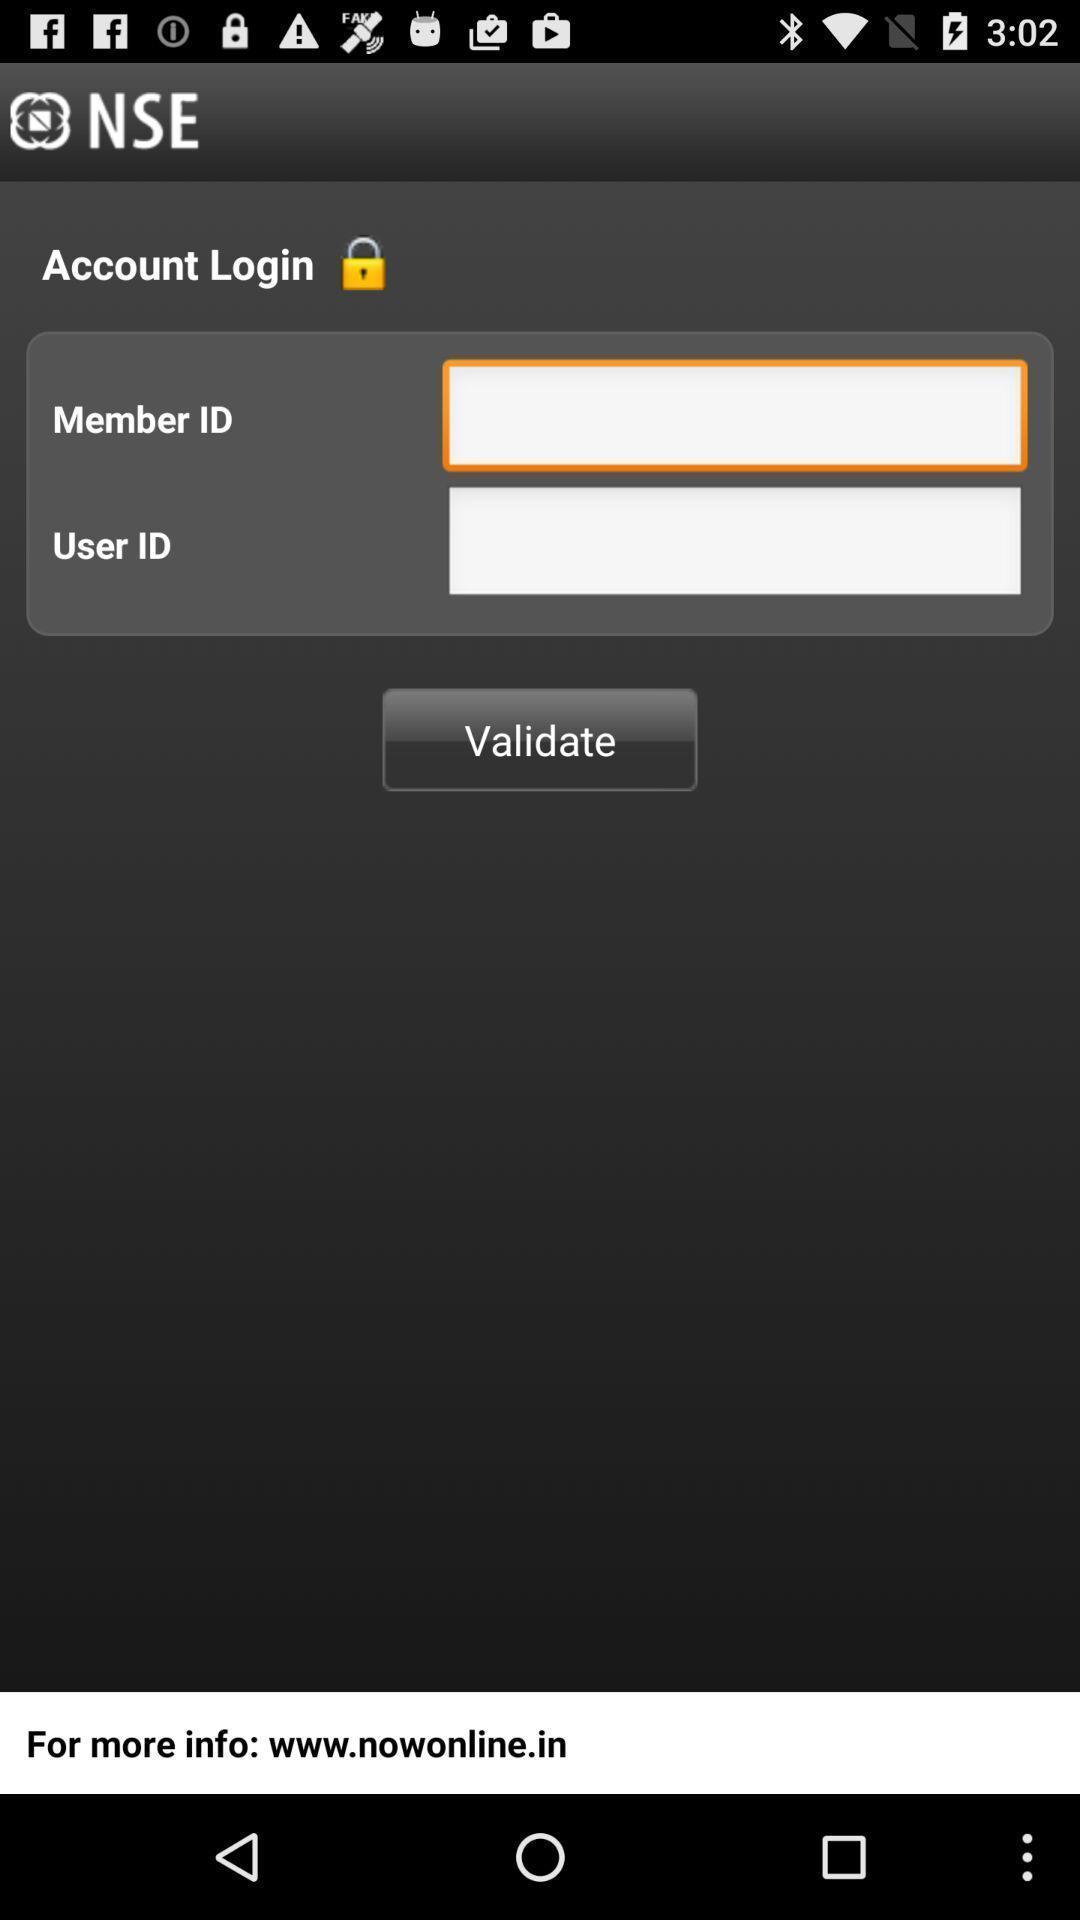Tell me about the visual elements in this screen capture. Screen displaying contents in account login page. 